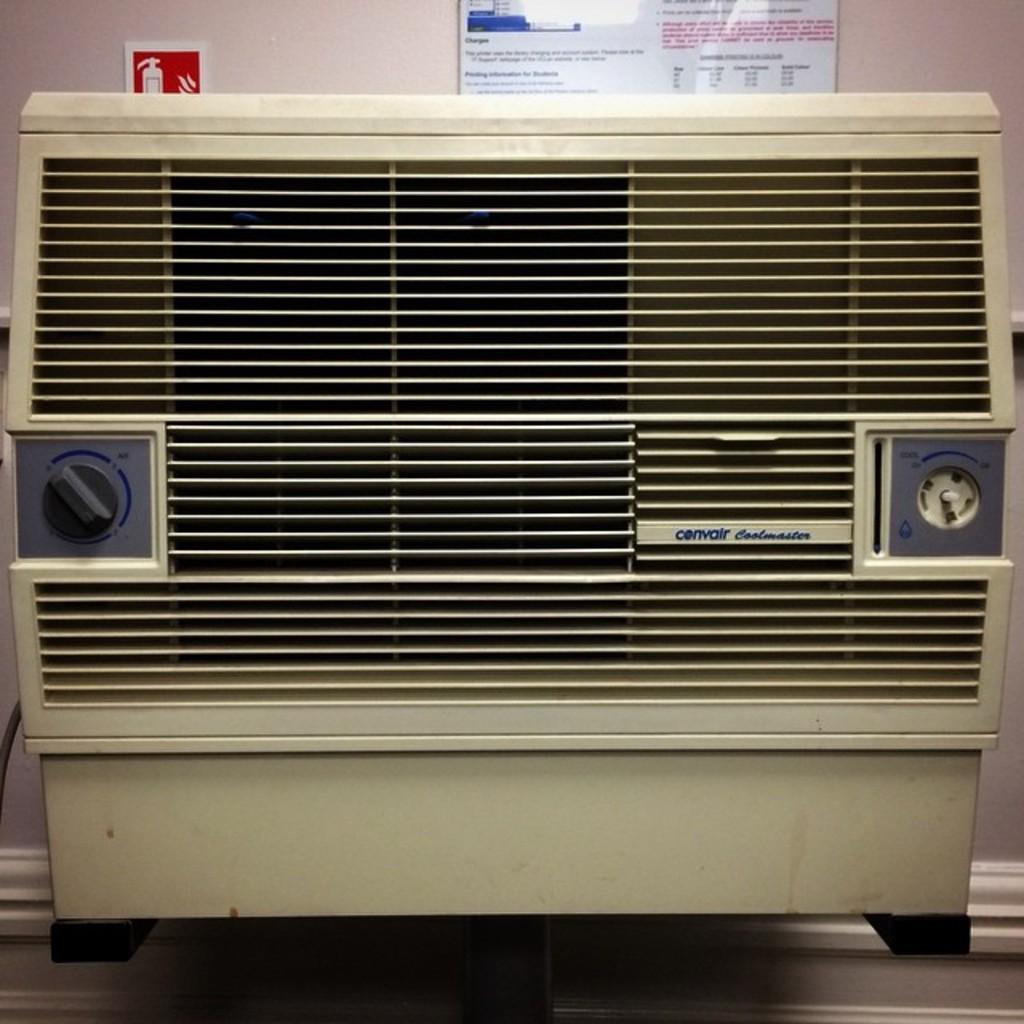Please provide a concise description of this image. In this picture I can see an air conditioner, and in the background there are boards attached to the wall. 